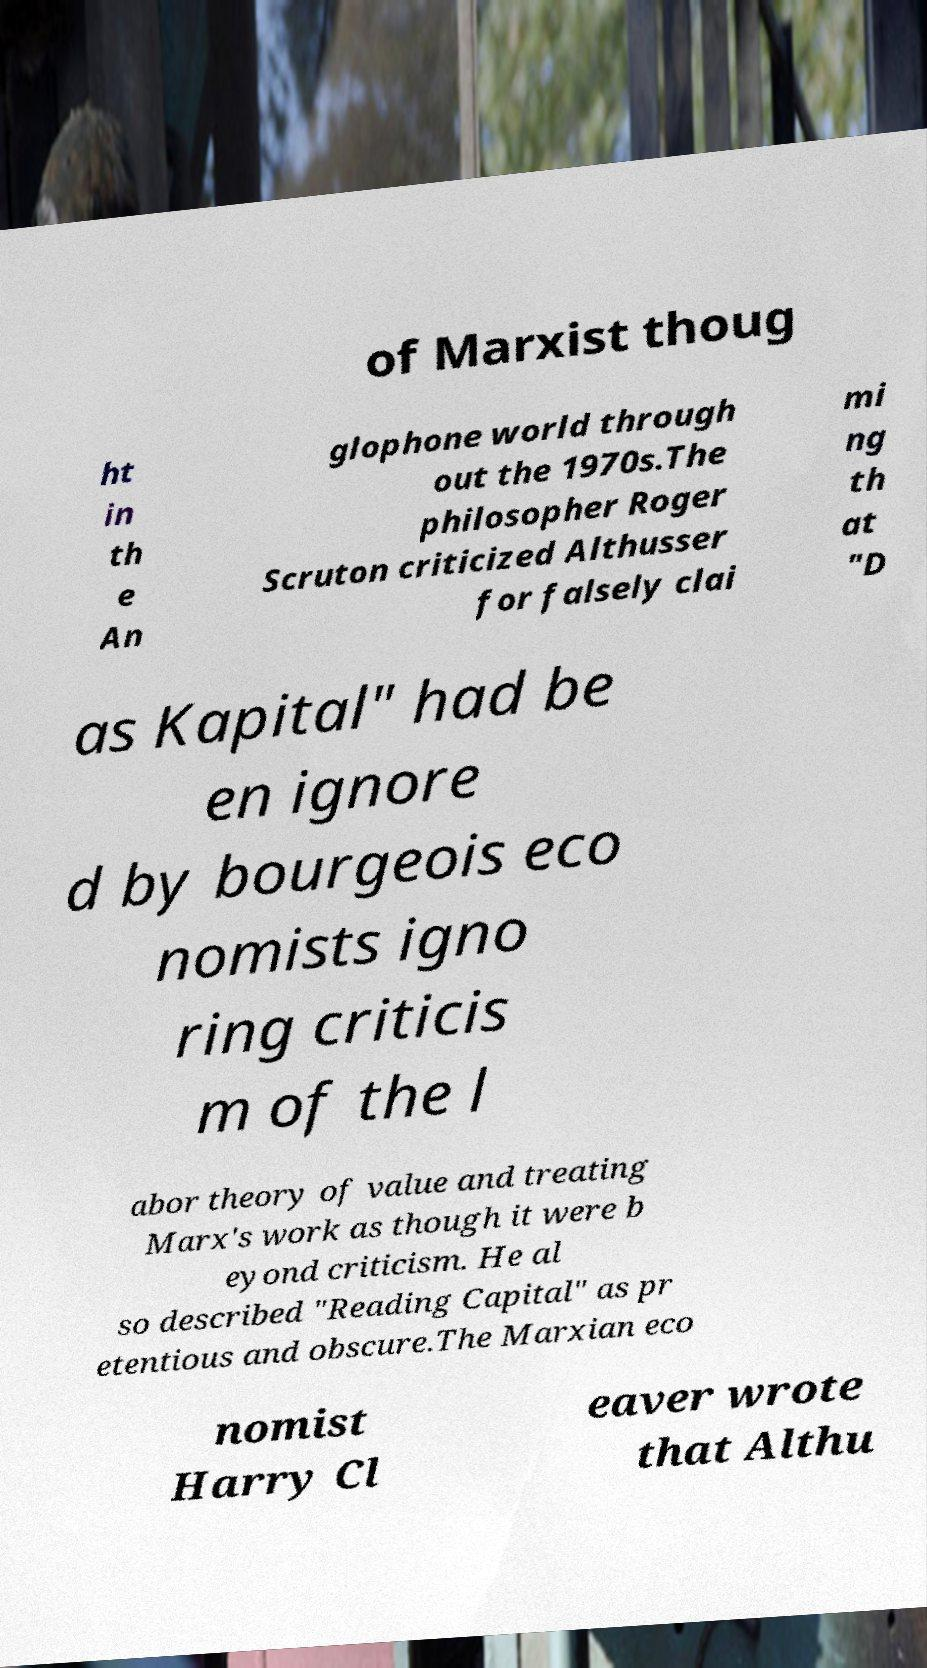Could you extract and type out the text from this image? of Marxist thoug ht in th e An glophone world through out the 1970s.The philosopher Roger Scruton criticized Althusser for falsely clai mi ng th at "D as Kapital" had be en ignore d by bourgeois eco nomists igno ring criticis m of the l abor theory of value and treating Marx's work as though it were b eyond criticism. He al so described "Reading Capital" as pr etentious and obscure.The Marxian eco nomist Harry Cl eaver wrote that Althu 